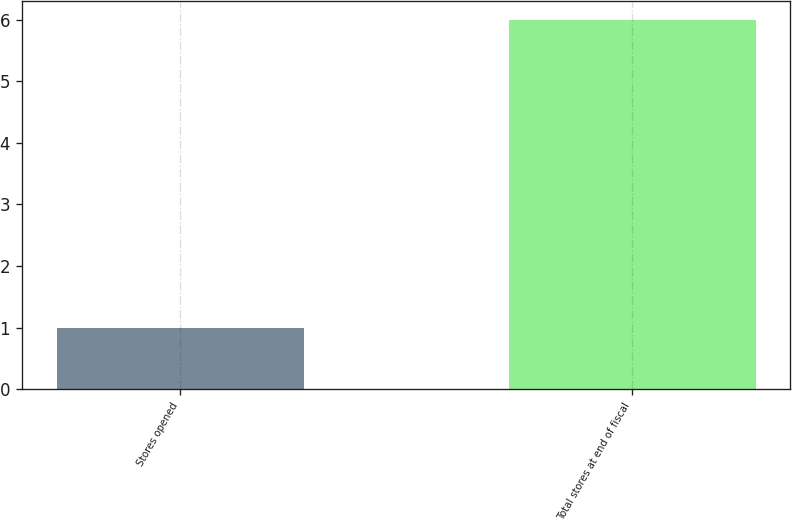Convert chart to OTSL. <chart><loc_0><loc_0><loc_500><loc_500><bar_chart><fcel>Stores opened<fcel>Total stores at end of fiscal<nl><fcel>1<fcel>6<nl></chart> 